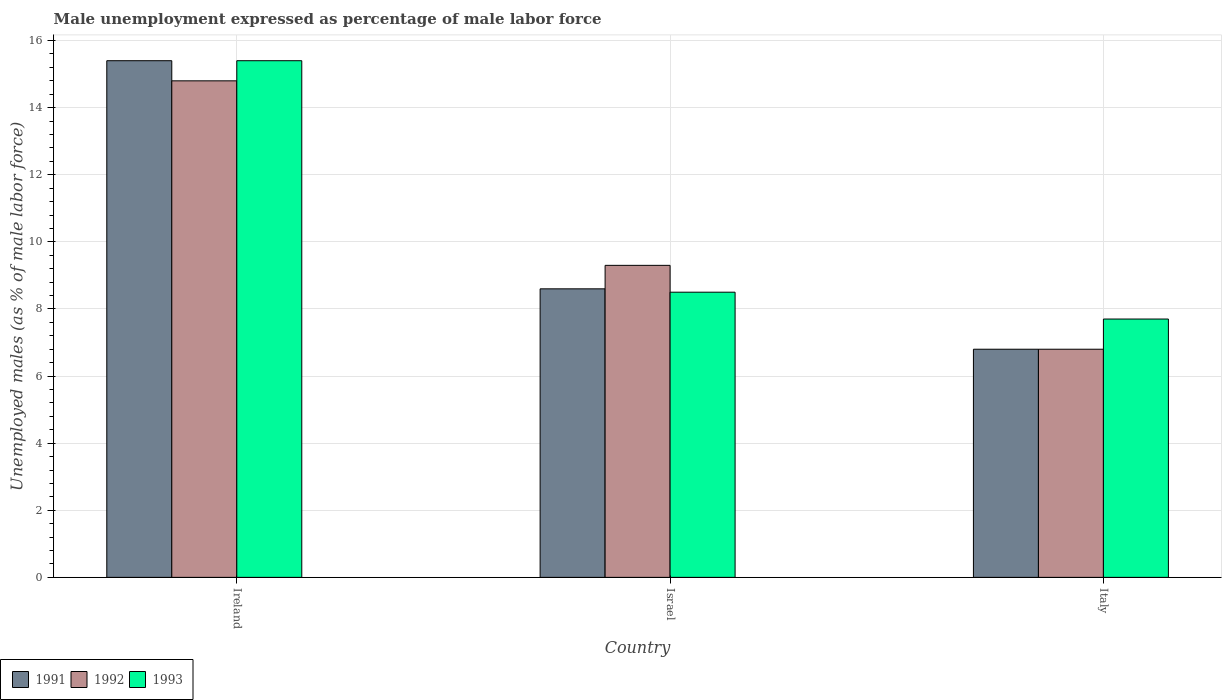How many different coloured bars are there?
Your answer should be compact. 3. How many groups of bars are there?
Keep it short and to the point. 3. Are the number of bars on each tick of the X-axis equal?
Provide a short and direct response. Yes. How many bars are there on the 1st tick from the right?
Your answer should be compact. 3. What is the label of the 1st group of bars from the left?
Provide a short and direct response. Ireland. In how many cases, is the number of bars for a given country not equal to the number of legend labels?
Your answer should be very brief. 0. What is the unemployment in males in in 1992 in Ireland?
Provide a succinct answer. 14.8. Across all countries, what is the maximum unemployment in males in in 1992?
Offer a terse response. 14.8. Across all countries, what is the minimum unemployment in males in in 1991?
Offer a very short reply. 6.8. In which country was the unemployment in males in in 1991 maximum?
Provide a succinct answer. Ireland. In which country was the unemployment in males in in 1991 minimum?
Your response must be concise. Italy. What is the total unemployment in males in in 1993 in the graph?
Offer a very short reply. 31.6. What is the difference between the unemployment in males in in 1992 in Ireland and that in Italy?
Offer a terse response. 8. What is the difference between the unemployment in males in in 1991 in Israel and the unemployment in males in in 1993 in Ireland?
Your answer should be compact. -6.8. What is the average unemployment in males in in 1993 per country?
Your answer should be compact. 10.53. What is the difference between the unemployment in males in of/in 1993 and unemployment in males in of/in 1992 in Italy?
Your response must be concise. 0.9. In how many countries, is the unemployment in males in in 1991 greater than 14.8 %?
Your answer should be compact. 1. What is the ratio of the unemployment in males in in 1991 in Ireland to that in Italy?
Your response must be concise. 2.26. What is the difference between the highest and the second highest unemployment in males in in 1991?
Offer a very short reply. 1.8. What is the difference between the highest and the lowest unemployment in males in in 1991?
Ensure brevity in your answer.  8.6. Is the sum of the unemployment in males in in 1993 in Ireland and Israel greater than the maximum unemployment in males in in 1992 across all countries?
Your answer should be very brief. Yes. How many bars are there?
Provide a succinct answer. 9. What is the difference between two consecutive major ticks on the Y-axis?
Offer a very short reply. 2. Where does the legend appear in the graph?
Give a very brief answer. Bottom left. What is the title of the graph?
Provide a succinct answer. Male unemployment expressed as percentage of male labor force. Does "1983" appear as one of the legend labels in the graph?
Keep it short and to the point. No. What is the label or title of the Y-axis?
Your response must be concise. Unemployed males (as % of male labor force). What is the Unemployed males (as % of male labor force) of 1991 in Ireland?
Offer a terse response. 15.4. What is the Unemployed males (as % of male labor force) in 1992 in Ireland?
Keep it short and to the point. 14.8. What is the Unemployed males (as % of male labor force) in 1993 in Ireland?
Ensure brevity in your answer.  15.4. What is the Unemployed males (as % of male labor force) of 1991 in Israel?
Ensure brevity in your answer.  8.6. What is the Unemployed males (as % of male labor force) of 1992 in Israel?
Provide a succinct answer. 9.3. What is the Unemployed males (as % of male labor force) of 1993 in Israel?
Provide a short and direct response. 8.5. What is the Unemployed males (as % of male labor force) in 1991 in Italy?
Offer a very short reply. 6.8. What is the Unemployed males (as % of male labor force) in 1992 in Italy?
Provide a succinct answer. 6.8. What is the Unemployed males (as % of male labor force) of 1993 in Italy?
Keep it short and to the point. 7.7. Across all countries, what is the maximum Unemployed males (as % of male labor force) of 1991?
Ensure brevity in your answer.  15.4. Across all countries, what is the maximum Unemployed males (as % of male labor force) of 1992?
Your answer should be compact. 14.8. Across all countries, what is the maximum Unemployed males (as % of male labor force) of 1993?
Offer a terse response. 15.4. Across all countries, what is the minimum Unemployed males (as % of male labor force) of 1991?
Your answer should be very brief. 6.8. Across all countries, what is the minimum Unemployed males (as % of male labor force) in 1992?
Ensure brevity in your answer.  6.8. Across all countries, what is the minimum Unemployed males (as % of male labor force) in 1993?
Ensure brevity in your answer.  7.7. What is the total Unemployed males (as % of male labor force) of 1991 in the graph?
Provide a short and direct response. 30.8. What is the total Unemployed males (as % of male labor force) in 1992 in the graph?
Provide a short and direct response. 30.9. What is the total Unemployed males (as % of male labor force) in 1993 in the graph?
Keep it short and to the point. 31.6. What is the difference between the Unemployed males (as % of male labor force) of 1991 in Ireland and that in Israel?
Offer a very short reply. 6.8. What is the difference between the Unemployed males (as % of male labor force) of 1993 in Ireland and that in Israel?
Offer a terse response. 6.9. What is the difference between the Unemployed males (as % of male labor force) of 1991 in Ireland and that in Italy?
Your answer should be compact. 8.6. What is the difference between the Unemployed males (as % of male labor force) of 1993 in Ireland and that in Italy?
Make the answer very short. 7.7. What is the difference between the Unemployed males (as % of male labor force) of 1991 in Israel and that in Italy?
Ensure brevity in your answer.  1.8. What is the difference between the Unemployed males (as % of male labor force) in 1992 in Israel and that in Italy?
Your response must be concise. 2.5. What is the difference between the Unemployed males (as % of male labor force) of 1991 in Ireland and the Unemployed males (as % of male labor force) of 1992 in Israel?
Your response must be concise. 6.1. What is the difference between the Unemployed males (as % of male labor force) in 1992 in Ireland and the Unemployed males (as % of male labor force) in 1993 in Italy?
Offer a terse response. 7.1. What is the difference between the Unemployed males (as % of male labor force) of 1991 in Israel and the Unemployed males (as % of male labor force) of 1992 in Italy?
Your answer should be compact. 1.8. What is the difference between the Unemployed males (as % of male labor force) in 1991 in Israel and the Unemployed males (as % of male labor force) in 1993 in Italy?
Provide a short and direct response. 0.9. What is the average Unemployed males (as % of male labor force) in 1991 per country?
Make the answer very short. 10.27. What is the average Unemployed males (as % of male labor force) of 1993 per country?
Make the answer very short. 10.53. What is the difference between the Unemployed males (as % of male labor force) of 1991 and Unemployed males (as % of male labor force) of 1992 in Ireland?
Offer a very short reply. 0.6. What is the difference between the Unemployed males (as % of male labor force) of 1991 and Unemployed males (as % of male labor force) of 1993 in Ireland?
Your response must be concise. 0. What is the difference between the Unemployed males (as % of male labor force) of 1991 and Unemployed males (as % of male labor force) of 1992 in Israel?
Provide a succinct answer. -0.7. What is the difference between the Unemployed males (as % of male labor force) of 1992 and Unemployed males (as % of male labor force) of 1993 in Israel?
Make the answer very short. 0.8. What is the difference between the Unemployed males (as % of male labor force) of 1991 and Unemployed males (as % of male labor force) of 1992 in Italy?
Provide a succinct answer. 0. What is the difference between the Unemployed males (as % of male labor force) in 1992 and Unemployed males (as % of male labor force) in 1993 in Italy?
Your answer should be compact. -0.9. What is the ratio of the Unemployed males (as % of male labor force) in 1991 in Ireland to that in Israel?
Your answer should be compact. 1.79. What is the ratio of the Unemployed males (as % of male labor force) of 1992 in Ireland to that in Israel?
Make the answer very short. 1.59. What is the ratio of the Unemployed males (as % of male labor force) of 1993 in Ireland to that in Israel?
Make the answer very short. 1.81. What is the ratio of the Unemployed males (as % of male labor force) in 1991 in Ireland to that in Italy?
Your answer should be compact. 2.26. What is the ratio of the Unemployed males (as % of male labor force) in 1992 in Ireland to that in Italy?
Offer a terse response. 2.18. What is the ratio of the Unemployed males (as % of male labor force) of 1993 in Ireland to that in Italy?
Give a very brief answer. 2. What is the ratio of the Unemployed males (as % of male labor force) in 1991 in Israel to that in Italy?
Make the answer very short. 1.26. What is the ratio of the Unemployed males (as % of male labor force) of 1992 in Israel to that in Italy?
Your answer should be very brief. 1.37. What is the ratio of the Unemployed males (as % of male labor force) in 1993 in Israel to that in Italy?
Your answer should be compact. 1.1. What is the difference between the highest and the second highest Unemployed males (as % of male labor force) in 1991?
Ensure brevity in your answer.  6.8. What is the difference between the highest and the second highest Unemployed males (as % of male labor force) in 1992?
Give a very brief answer. 5.5. What is the difference between the highest and the second highest Unemployed males (as % of male labor force) in 1993?
Make the answer very short. 6.9. What is the difference between the highest and the lowest Unemployed males (as % of male labor force) of 1993?
Your answer should be compact. 7.7. 